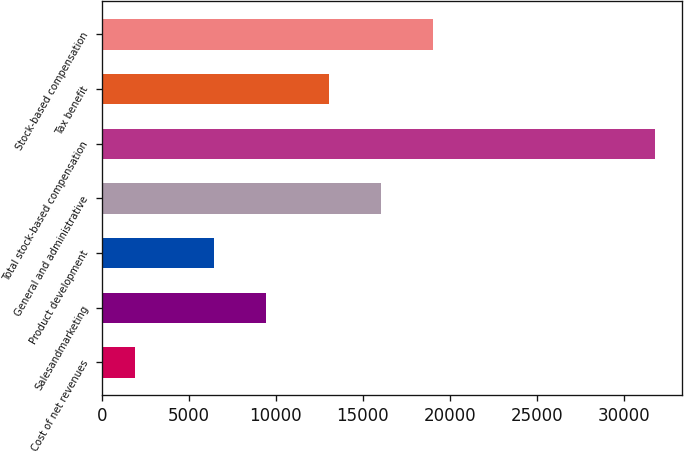Convert chart. <chart><loc_0><loc_0><loc_500><loc_500><bar_chart><fcel>Cost of net revenues<fcel>Salesandmarketing<fcel>Product development<fcel>General and administrative<fcel>Total stock-based compensation<fcel>Tax benefit<fcel>Stock-based compensation<nl><fcel>1881<fcel>9457.1<fcel>6468<fcel>16012.1<fcel>31772<fcel>13023<fcel>19001.2<nl></chart> 